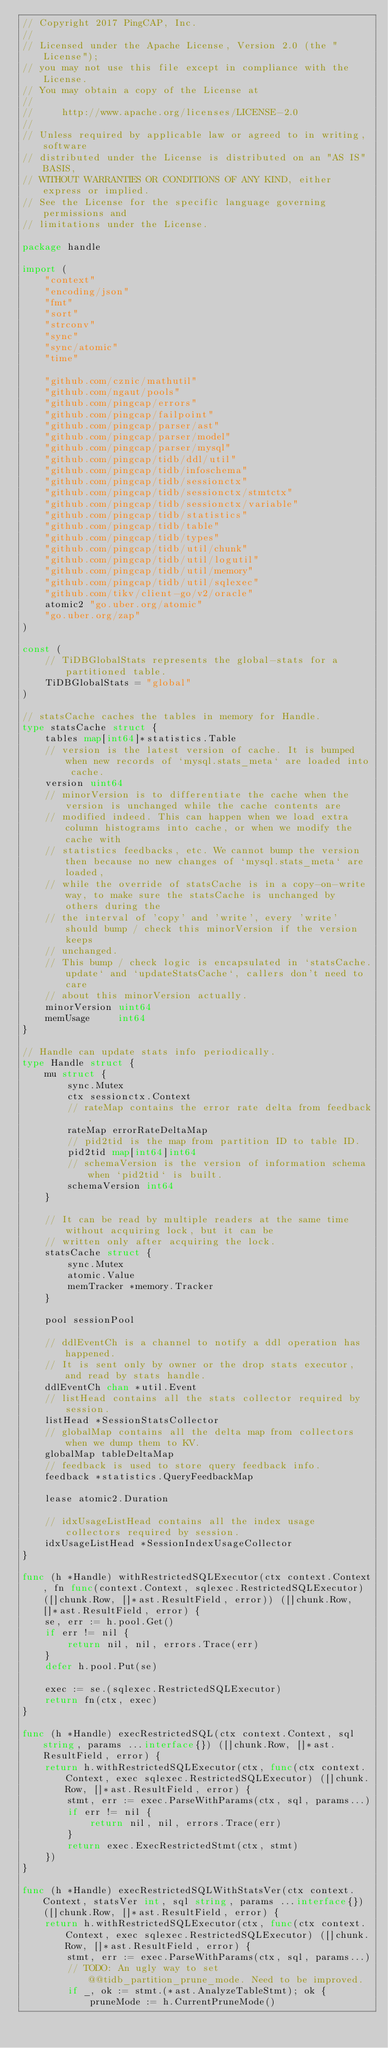Convert code to text. <code><loc_0><loc_0><loc_500><loc_500><_Go_>// Copyright 2017 PingCAP, Inc.
//
// Licensed under the Apache License, Version 2.0 (the "License");
// you may not use this file except in compliance with the License.
// You may obtain a copy of the License at
//
//     http://www.apache.org/licenses/LICENSE-2.0
//
// Unless required by applicable law or agreed to in writing, software
// distributed under the License is distributed on an "AS IS" BASIS,
// WITHOUT WARRANTIES OR CONDITIONS OF ANY KIND, either express or implied.
// See the License for the specific language governing permissions and
// limitations under the License.

package handle

import (
	"context"
	"encoding/json"
	"fmt"
	"sort"
	"strconv"
	"sync"
	"sync/atomic"
	"time"

	"github.com/cznic/mathutil"
	"github.com/ngaut/pools"
	"github.com/pingcap/errors"
	"github.com/pingcap/failpoint"
	"github.com/pingcap/parser/ast"
	"github.com/pingcap/parser/model"
	"github.com/pingcap/parser/mysql"
	"github.com/pingcap/tidb/ddl/util"
	"github.com/pingcap/tidb/infoschema"
	"github.com/pingcap/tidb/sessionctx"
	"github.com/pingcap/tidb/sessionctx/stmtctx"
	"github.com/pingcap/tidb/sessionctx/variable"
	"github.com/pingcap/tidb/statistics"
	"github.com/pingcap/tidb/table"
	"github.com/pingcap/tidb/types"
	"github.com/pingcap/tidb/util/chunk"
	"github.com/pingcap/tidb/util/logutil"
	"github.com/pingcap/tidb/util/memory"
	"github.com/pingcap/tidb/util/sqlexec"
	"github.com/tikv/client-go/v2/oracle"
	atomic2 "go.uber.org/atomic"
	"go.uber.org/zap"
)

const (
	// TiDBGlobalStats represents the global-stats for a partitioned table.
	TiDBGlobalStats = "global"
)

// statsCache caches the tables in memory for Handle.
type statsCache struct {
	tables map[int64]*statistics.Table
	// version is the latest version of cache. It is bumped when new records of `mysql.stats_meta` are loaded into cache.
	version uint64
	// minorVersion is to differentiate the cache when the version is unchanged while the cache contents are
	// modified indeed. This can happen when we load extra column histograms into cache, or when we modify the cache with
	// statistics feedbacks, etc. We cannot bump the version then because no new changes of `mysql.stats_meta` are loaded,
	// while the override of statsCache is in a copy-on-write way, to make sure the statsCache is unchanged by others during the
	// the interval of 'copy' and 'write', every 'write' should bump / check this minorVersion if the version keeps
	// unchanged.
	// This bump / check logic is encapsulated in `statsCache.update` and `updateStatsCache`, callers don't need to care
	// about this minorVersion actually.
	minorVersion uint64
	memUsage     int64
}

// Handle can update stats info periodically.
type Handle struct {
	mu struct {
		sync.Mutex
		ctx sessionctx.Context
		// rateMap contains the error rate delta from feedback.
		rateMap errorRateDeltaMap
		// pid2tid is the map from partition ID to table ID.
		pid2tid map[int64]int64
		// schemaVersion is the version of information schema when `pid2tid` is built.
		schemaVersion int64
	}

	// It can be read by multiple readers at the same time without acquiring lock, but it can be
	// written only after acquiring the lock.
	statsCache struct {
		sync.Mutex
		atomic.Value
		memTracker *memory.Tracker
	}

	pool sessionPool

	// ddlEventCh is a channel to notify a ddl operation has happened.
	// It is sent only by owner or the drop stats executor, and read by stats handle.
	ddlEventCh chan *util.Event
	// listHead contains all the stats collector required by session.
	listHead *SessionStatsCollector
	// globalMap contains all the delta map from collectors when we dump them to KV.
	globalMap tableDeltaMap
	// feedback is used to store query feedback info.
	feedback *statistics.QueryFeedbackMap

	lease atomic2.Duration

	// idxUsageListHead contains all the index usage collectors required by session.
	idxUsageListHead *SessionIndexUsageCollector
}

func (h *Handle) withRestrictedSQLExecutor(ctx context.Context, fn func(context.Context, sqlexec.RestrictedSQLExecutor) ([]chunk.Row, []*ast.ResultField, error)) ([]chunk.Row, []*ast.ResultField, error) {
	se, err := h.pool.Get()
	if err != nil {
		return nil, nil, errors.Trace(err)
	}
	defer h.pool.Put(se)

	exec := se.(sqlexec.RestrictedSQLExecutor)
	return fn(ctx, exec)
}

func (h *Handle) execRestrictedSQL(ctx context.Context, sql string, params ...interface{}) ([]chunk.Row, []*ast.ResultField, error) {
	return h.withRestrictedSQLExecutor(ctx, func(ctx context.Context, exec sqlexec.RestrictedSQLExecutor) ([]chunk.Row, []*ast.ResultField, error) {
		stmt, err := exec.ParseWithParams(ctx, sql, params...)
		if err != nil {
			return nil, nil, errors.Trace(err)
		}
		return exec.ExecRestrictedStmt(ctx, stmt)
	})
}

func (h *Handle) execRestrictedSQLWithStatsVer(ctx context.Context, statsVer int, sql string, params ...interface{}) ([]chunk.Row, []*ast.ResultField, error) {
	return h.withRestrictedSQLExecutor(ctx, func(ctx context.Context, exec sqlexec.RestrictedSQLExecutor) ([]chunk.Row, []*ast.ResultField, error) {
		stmt, err := exec.ParseWithParams(ctx, sql, params...)
		// TODO: An ugly way to set @@tidb_partition_prune_mode. Need to be improved.
		if _, ok := stmt.(*ast.AnalyzeTableStmt); ok {
			pruneMode := h.CurrentPruneMode()</code> 